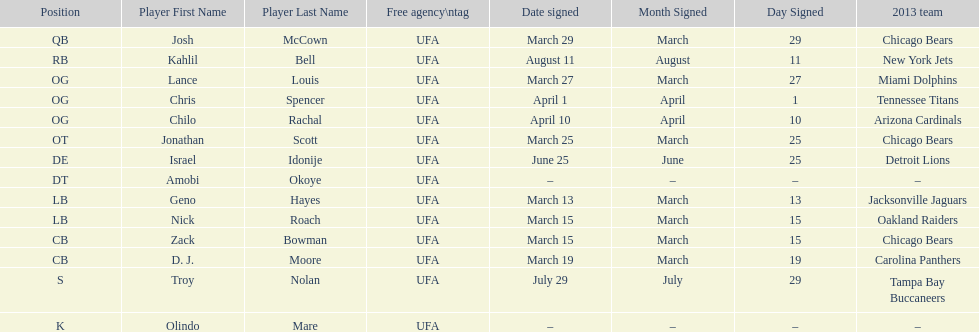How many free agents did this team pick up this season? 14. 